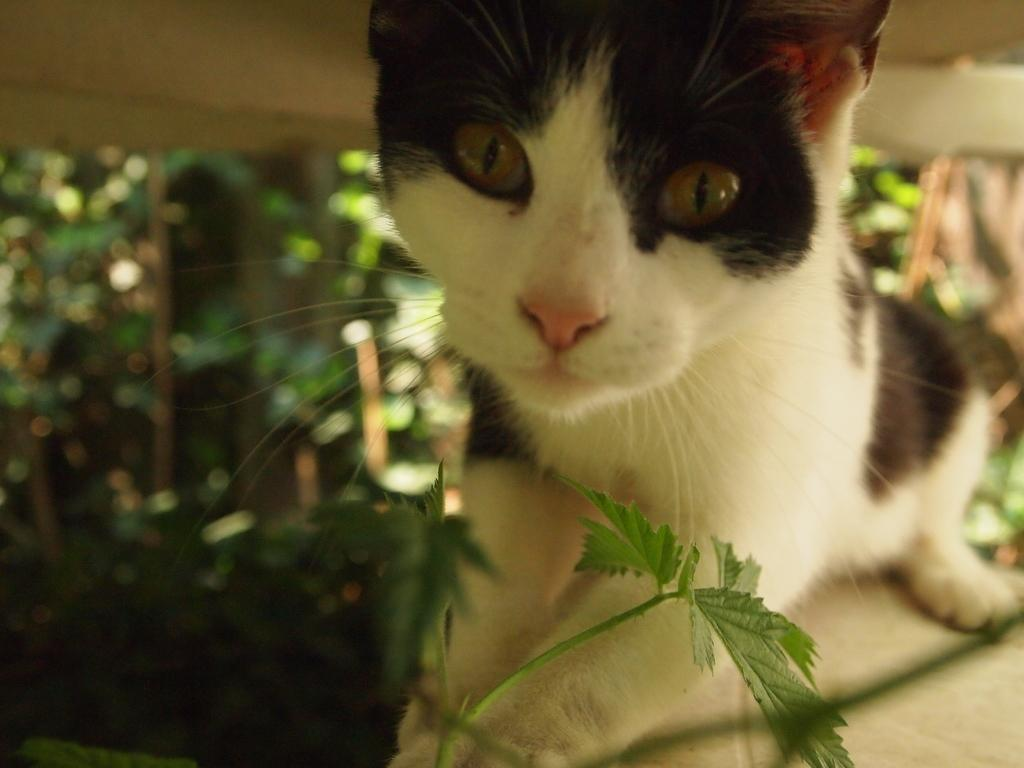What type of animal is in the image? There is a black and white cat in the image. What else can be seen in the image besides the cat? There is a plant in the image. Can you describe the background of the image? The background has a blurred view. What is the distribution of the thumb in the image? There is no thumb present in the image. 